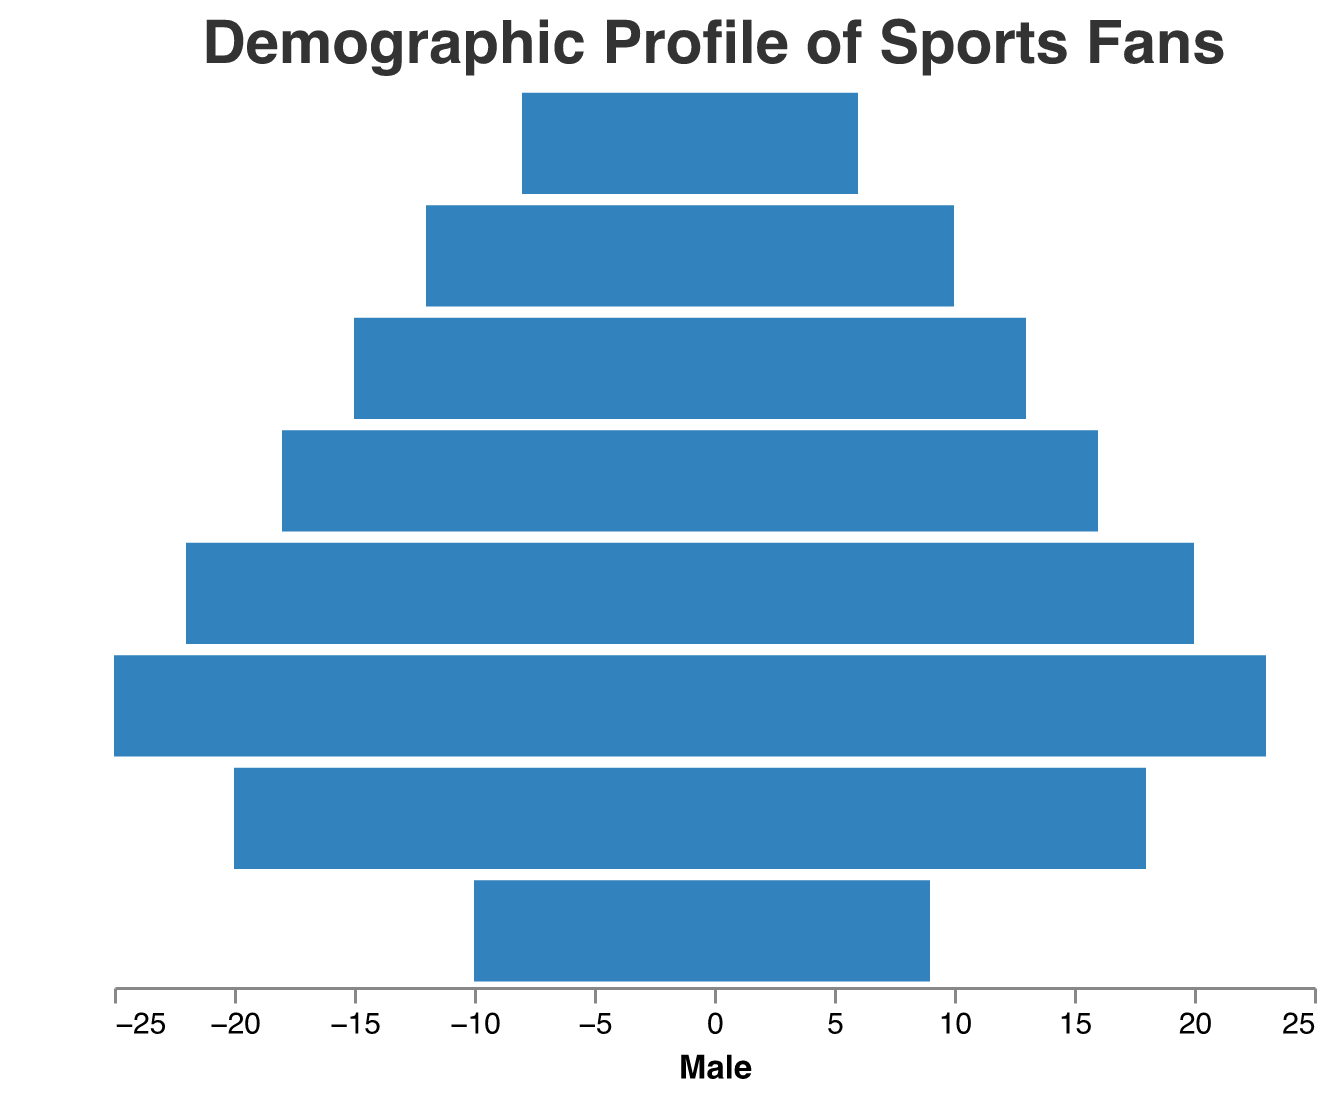Which age group has the highest number of male sports fans? Look at the bars on the left side of the pyramid. The tallest bar represents the age group with the highest number of male fans.
Answer: 18-24 What's the total number of female sports fans in the 45-54 age group? Refer to the height of the bar on the right side for the age group 45-54 and count the value.
Answer: 13 Compare the number of male fans and female fans in the 25-34 age group. Which gender has more fans? Check the two bars for the 25-34 age group, one on the left and one on the right. Compare their lengths.
Answer: Male What's the difference in the number of female sports fans between the 18-24 and 35-44 age groups? Note the lengths of the bars on the right side for the age groups 18-24 and 35-44. Subtract the latter from the former.
Answer: 7 Which age group has the smallest difference in the number of male and female sports fans? Identify the age groups by comparing the lengths of the bars on both sides and choosing the group with the smallest bar length difference.
Answer: 55-64 What is the total number of sports fans (both male and female) in the 13-17 age group? Sum the values of male and female fans in the 13-17 age group by adding the lengths of both bars.
Answer: 38 Which age group shows the largest gender disparity in terms of sports fans? Compare the length differences between male and female bars for each age group and identify the largest difference.
Answer: 18-24 What percentage of the 18-24 age group's fans are females? Calculate the percentage using (number of female fans in the 18-24 group / total number of fans in the 18-24 group) * 100. (23 / (25 + 23)) * 100 ≈ 47.92%.
Answer: approximately 47.92% How many more male sports fans are there in the 35-44 age group compared to the 65+ age group? Subtract the number of male fans in the 65+ group from the number of male fans in the 35-44 group by comparing their bar lengths.
Answer: 10 Between which two consecutive age groups does the number of male fans increase the most? Compare the male fan numbers between consecutive age groups and calculate the differences. The largest difference indicates the answer.
Answer: 18-24 to 25-34 